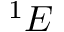<formula> <loc_0><loc_0><loc_500><loc_500>^ { 1 } E</formula> 